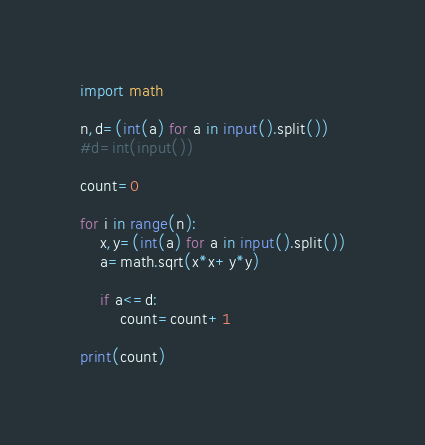<code> <loc_0><loc_0><loc_500><loc_500><_Python_>import math

n,d=(int(a) for a in input().split())
#d=int(input())

count=0

for i in range(n):
    x,y=(int(a) for a in input().split())
    a=math.sqrt(x*x+y*y)
    
    if a<=d:
        count=count+1

print(count)
</code> 